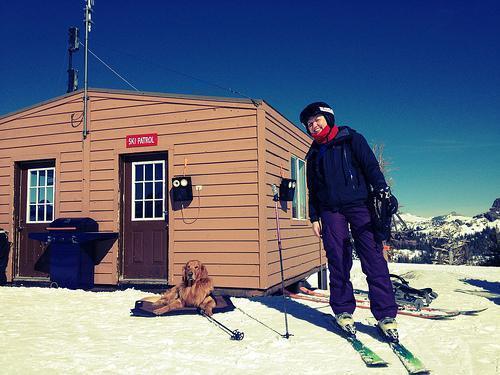How many doors does the building have?
Give a very brief answer. 2. 